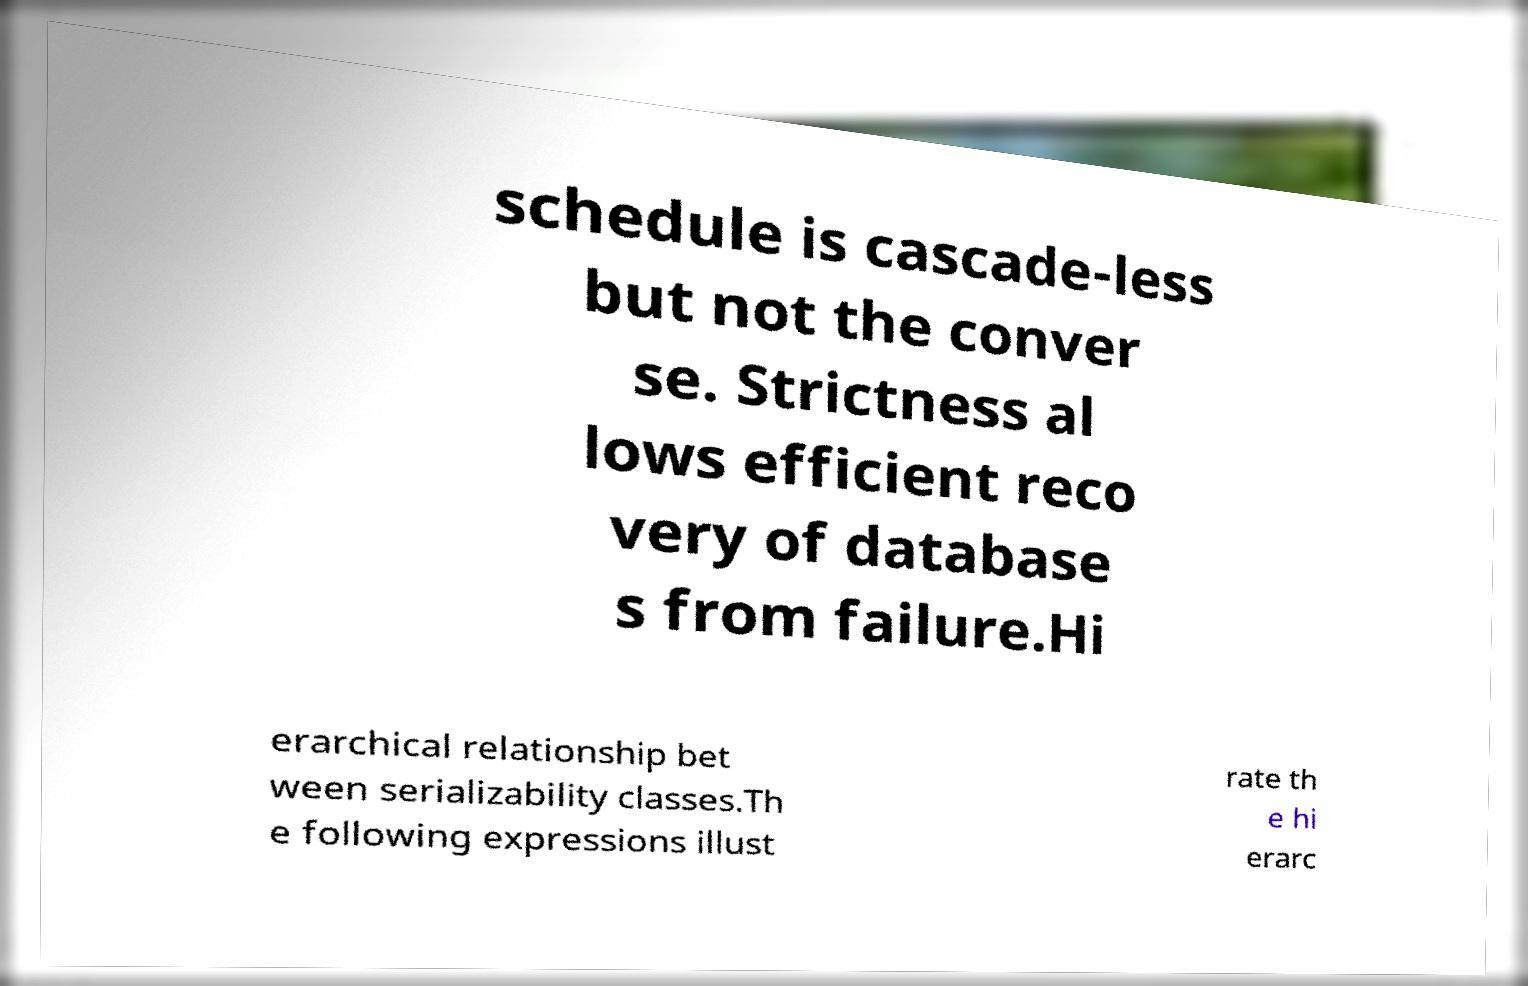Could you extract and type out the text from this image? schedule is cascade-less but not the conver se. Strictness al lows efficient reco very of database s from failure.Hi erarchical relationship bet ween serializability classes.Th e following expressions illust rate th e hi erarc 